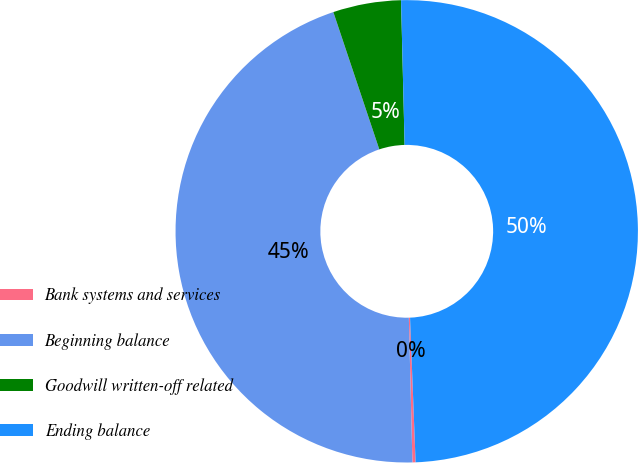Convert chart to OTSL. <chart><loc_0><loc_0><loc_500><loc_500><pie_chart><fcel>Bank systems and services<fcel>Beginning balance<fcel>Goodwill written-off related<fcel>Ending balance<nl><fcel>0.22%<fcel>45.25%<fcel>4.75%<fcel>49.78%<nl></chart> 